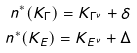Convert formula to latex. <formula><loc_0><loc_0><loc_500><loc_500>n ^ { \ast } ( K _ { \Gamma } ) = K _ { \Gamma ^ { \nu } } + \delta \\ n ^ { \ast } ( K _ { E } ) = K _ { E ^ { \nu } } + \Delta</formula> 